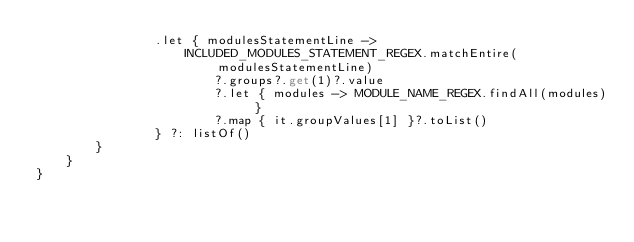Convert code to text. <code><loc_0><loc_0><loc_500><loc_500><_Kotlin_>                .let { modulesStatementLine ->
                    INCLUDED_MODULES_STATEMENT_REGEX.matchEntire(modulesStatementLine)
                        ?.groups?.get(1)?.value
                        ?.let { modules -> MODULE_NAME_REGEX.findAll(modules) }
                        ?.map { it.groupValues[1] }?.toList()
                } ?: listOf()
        }
    }
}
</code> 